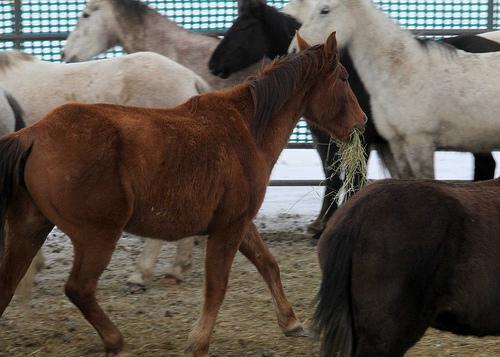How many horse heads are in the picture?
Give a very brief answer. 4. 